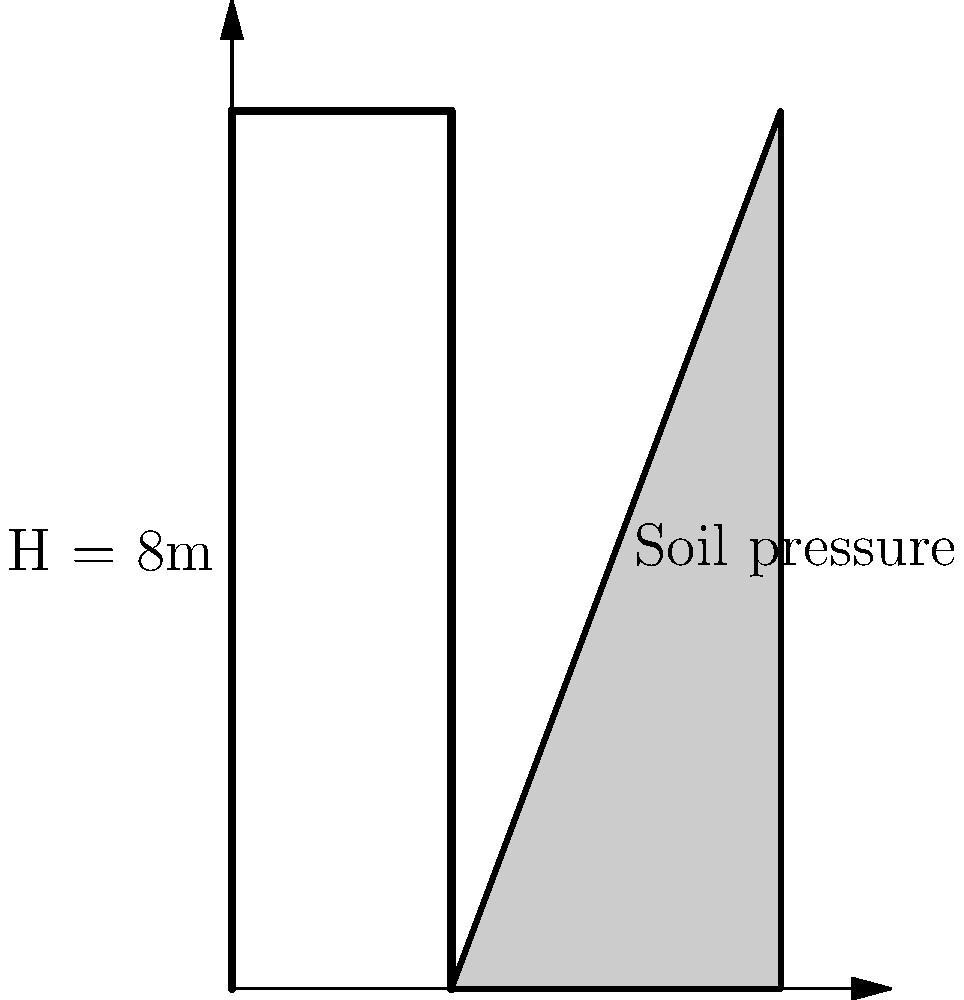As a civil engineer tasked with designing a retaining wall for a public infrastructure project, you're presented with the soil pressure diagram shown above. The wall height is 8m, and the soil pressure distribution is triangular, reaching a maximum at the base. Given that the allowable stress for the concrete is 5 MPa and the unit weight of concrete is 24 kN/m³, estimate the minimum thickness of the retaining wall to the nearest 0.1m. Assume a safety factor of 1.5 for overturning. Let's approach this step-by-step, keeping in mind the importance of integrity in public service projects:

1) First, calculate the total soil pressure force:
   Area of pressure diagram = $\frac{1}{2} \times 8m \times 3m = 12m²$
   Assuming a unit width of 1m, the total force F = $12 \times \gamma$ (where $\gamma$ is the unit weight of soil)

2) The moment arm for this force is at H/3 from the base:
   Moment arm = $8m / 3 = 2.67m$

3) The overturning moment is:
   $M_o = F \times 2.67m = 32\gamma$ m³

4) For stability, the resisting moment must be greater than the overturning moment by a factor of 1.5:
   $M_r = 1.5 \times 32\gamma = 48\gamma$ m³

5) The resisting moment is provided by the weight of the wall:
   $M_r = \frac{1}{2} \times t \times H^2 \times \gamma_c$
   Where t is the thickness and $\gamma_c$ is the unit weight of concrete (24 kN/m³)

6) Equating these:
   $48\gamma = \frac{1}{2} \times t \times 8^2 \times 24$
   $48\gamma = 768t$

7) To find t, we need to know $\gamma$. We can use the allowable stress condition:
   $\frac{F}{t} \leq 5000$ kPa
   $\frac{12\gamma}{t} \leq 5000$

8) Substituting this into the equation from step 6:
   $48 \times \frac{5000t}{12} = 768t$
   $20000t = 768t$
   $t = 0.0384m$

9) Rounding up to the nearest 0.1m for practical purposes and additional safety:
   $t = 0.1m$

This thickness ensures both stability against overturning and allowable stress conditions are met, prioritizing public safety.
Answer: 0.1m 